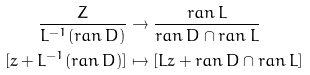<formula> <loc_0><loc_0><loc_500><loc_500>\frac { Z } { L ^ { - 1 } ( r a n \, D ) } & \to \frac { r a n \, L } { r a n \, D \cap r a n \, L } \\ [ z + L ^ { - 1 } ( r a n \, D ) ] & \mapsto [ L z + r a n \, D \cap r a n \, L ]</formula> 